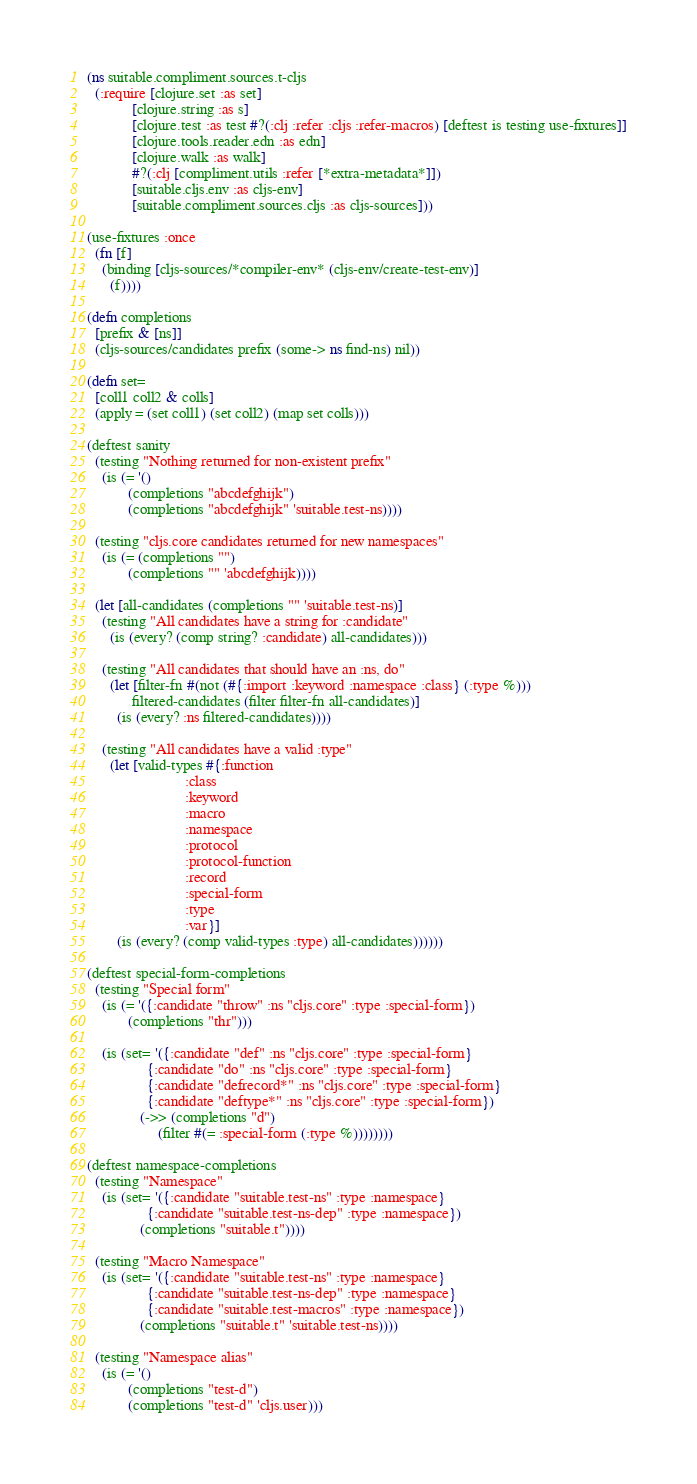Convert code to text. <code><loc_0><loc_0><loc_500><loc_500><_Clojure_>(ns suitable.compliment.sources.t-cljs
  (:require [clojure.set :as set]
            [clojure.string :as s]
            [clojure.test :as test #?(:clj :refer :cljs :refer-macros) [deftest is testing use-fixtures]]
            [clojure.tools.reader.edn :as edn]
            [clojure.walk :as walk]
            #?(:clj [compliment.utils :refer [*extra-metadata*]])
            [suitable.cljs.env :as cljs-env]
            [suitable.compliment.sources.cljs :as cljs-sources]))

(use-fixtures :once
  (fn [f]
    (binding [cljs-sources/*compiler-env* (cljs-env/create-test-env)]
      (f))))

(defn completions
  [prefix & [ns]]
  (cljs-sources/candidates prefix (some-> ns find-ns) nil))

(defn set=
  [coll1 coll2 & colls]
  (apply = (set coll1) (set coll2) (map set colls)))

(deftest sanity
  (testing "Nothing returned for non-existent prefix"
    (is (= '()
           (completions "abcdefghijk")
           (completions "abcdefghijk" 'suitable.test-ns))))

  (testing "cljs.core candidates returned for new namespaces"
    (is (= (completions "")
           (completions "" 'abcdefghijk))))

  (let [all-candidates (completions "" 'suitable.test-ns)]
    (testing "All candidates have a string for :candidate"
      (is (every? (comp string? :candidate) all-candidates)))

    (testing "All candidates that should have an :ns, do"
      (let [filter-fn #(not (#{:import :keyword :namespace :class} (:type %)))
            filtered-candidates (filter filter-fn all-candidates)]
        (is (every? :ns filtered-candidates))))

    (testing "All candidates have a valid :type"
      (let [valid-types #{:function
                          :class
                          :keyword
                          :macro
                          :namespace
                          :protocol
                          :protocol-function
                          :record
                          :special-form
                          :type
                          :var}]
        (is (every? (comp valid-types :type) all-candidates))))))

(deftest special-form-completions
  (testing "Special form"
    (is (= '({:candidate "throw" :ns "cljs.core" :type :special-form})
           (completions "thr")))

    (is (set= '({:candidate "def" :ns "cljs.core" :type :special-form}
                {:candidate "do" :ns "cljs.core" :type :special-form}
                {:candidate "defrecord*" :ns "cljs.core" :type :special-form}
                {:candidate "deftype*" :ns "cljs.core" :type :special-form})
              (->> (completions "d")
                   (filter #(= :special-form (:type %))))))))

(deftest namespace-completions
  (testing "Namespace"
    (is (set= '({:candidate "suitable.test-ns" :type :namespace}
                {:candidate "suitable.test-ns-dep" :type :namespace})
              (completions "suitable.t"))))

  (testing "Macro Namespace"
    (is (set= '({:candidate "suitable.test-ns" :type :namespace}
                {:candidate "suitable.test-ns-dep" :type :namespace}
                {:candidate "suitable.test-macros" :type :namespace})
              (completions "suitable.t" 'suitable.test-ns))))

  (testing "Namespace alias"
    (is (= '()
           (completions "test-d")
           (completions "test-d" 'cljs.user)))</code> 